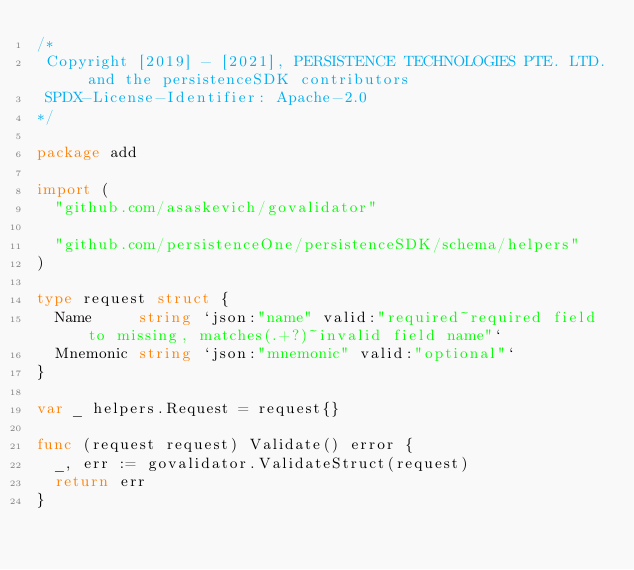Convert code to text. <code><loc_0><loc_0><loc_500><loc_500><_Go_>/*
 Copyright [2019] - [2021], PERSISTENCE TECHNOLOGIES PTE. LTD. and the persistenceSDK contributors
 SPDX-License-Identifier: Apache-2.0
*/

package add

import (
	"github.com/asaskevich/govalidator"

	"github.com/persistenceOne/persistenceSDK/schema/helpers"
)

type request struct {
	Name     string `json:"name" valid:"required~required field to missing, matches(.+?)~invalid field name"`
	Mnemonic string `json:"mnemonic" valid:"optional"`
}

var _ helpers.Request = request{}

func (request request) Validate() error {
	_, err := govalidator.ValidateStruct(request)
	return err
}
</code> 